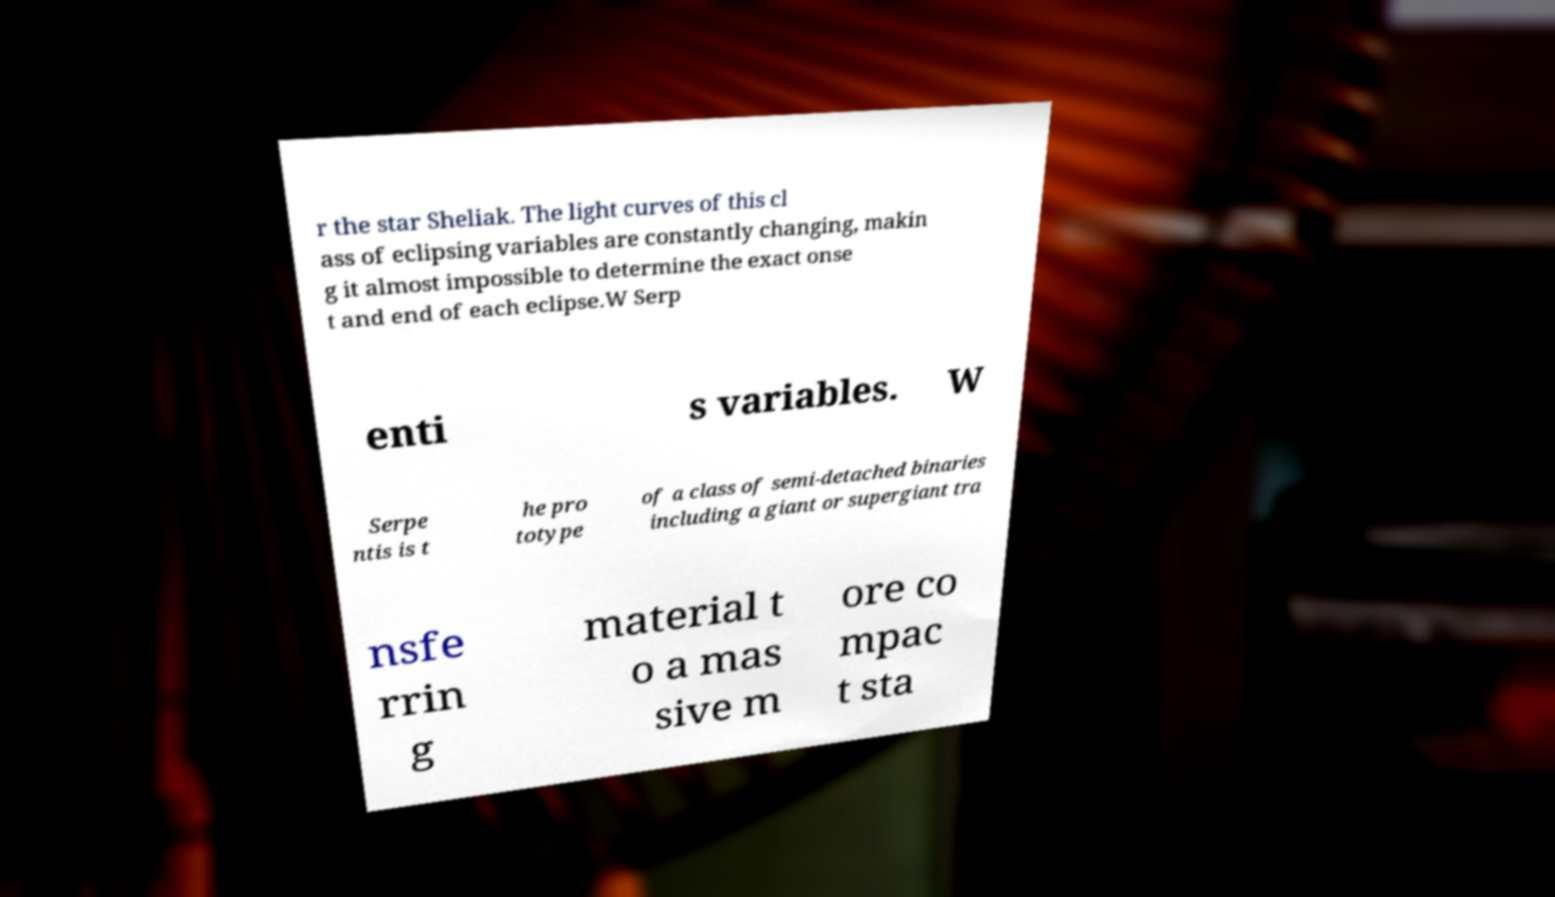Could you assist in decoding the text presented in this image and type it out clearly? r the star Sheliak. The light curves of this cl ass of eclipsing variables are constantly changing, makin g it almost impossible to determine the exact onse t and end of each eclipse.W Serp enti s variables. W Serpe ntis is t he pro totype of a class of semi-detached binaries including a giant or supergiant tra nsfe rrin g material t o a mas sive m ore co mpac t sta 